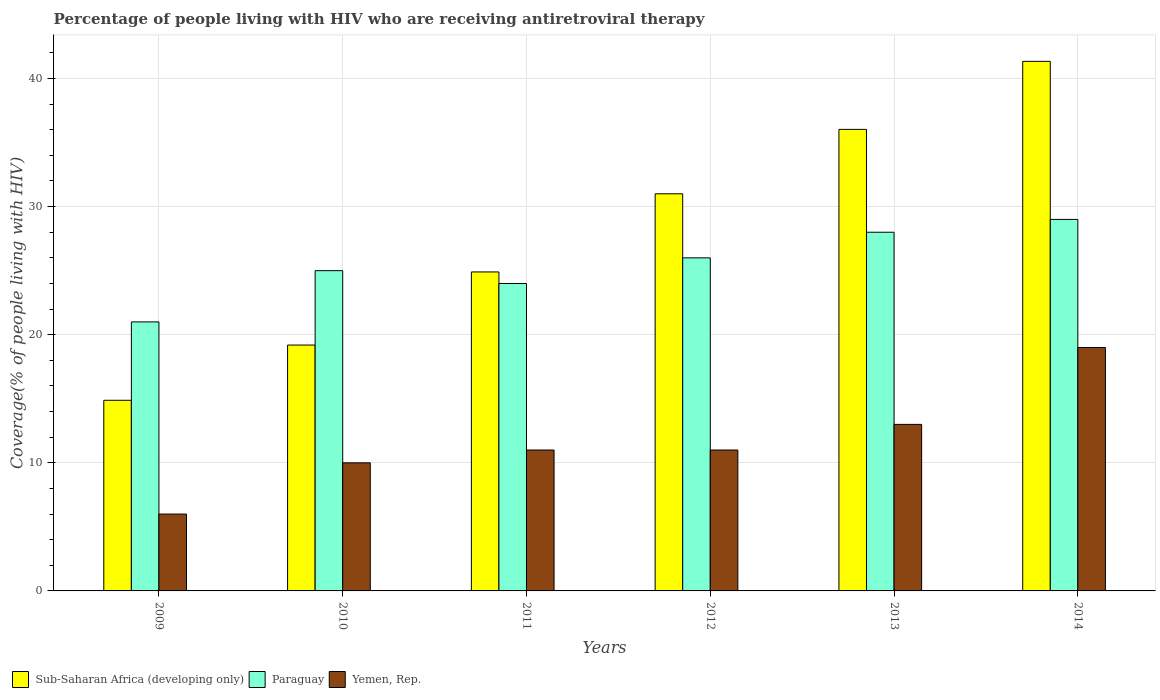How many different coloured bars are there?
Keep it short and to the point. 3. Are the number of bars per tick equal to the number of legend labels?
Keep it short and to the point. Yes. How many bars are there on the 6th tick from the right?
Your response must be concise. 3. What is the label of the 3rd group of bars from the left?
Give a very brief answer. 2011. What is the percentage of the HIV infected people who are receiving antiretroviral therapy in Sub-Saharan Africa (developing only) in 2013?
Offer a terse response. 36.03. Across all years, what is the maximum percentage of the HIV infected people who are receiving antiretroviral therapy in Sub-Saharan Africa (developing only)?
Your answer should be very brief. 41.34. Across all years, what is the minimum percentage of the HIV infected people who are receiving antiretroviral therapy in Sub-Saharan Africa (developing only)?
Give a very brief answer. 14.88. In which year was the percentage of the HIV infected people who are receiving antiretroviral therapy in Paraguay maximum?
Your response must be concise. 2014. In which year was the percentage of the HIV infected people who are receiving antiretroviral therapy in Paraguay minimum?
Ensure brevity in your answer.  2009. What is the total percentage of the HIV infected people who are receiving antiretroviral therapy in Paraguay in the graph?
Provide a succinct answer. 153. What is the difference between the percentage of the HIV infected people who are receiving antiretroviral therapy in Paraguay in 2012 and that in 2014?
Offer a terse response. -3. What is the difference between the percentage of the HIV infected people who are receiving antiretroviral therapy in Sub-Saharan Africa (developing only) in 2011 and the percentage of the HIV infected people who are receiving antiretroviral therapy in Yemen, Rep. in 2012?
Offer a terse response. 13.9. What is the average percentage of the HIV infected people who are receiving antiretroviral therapy in Sub-Saharan Africa (developing only) per year?
Your response must be concise. 27.89. In the year 2012, what is the difference between the percentage of the HIV infected people who are receiving antiretroviral therapy in Paraguay and percentage of the HIV infected people who are receiving antiretroviral therapy in Yemen, Rep.?
Offer a very short reply. 15. In how many years, is the percentage of the HIV infected people who are receiving antiretroviral therapy in Paraguay greater than 28 %?
Make the answer very short. 1. What is the ratio of the percentage of the HIV infected people who are receiving antiretroviral therapy in Yemen, Rep. in 2013 to that in 2014?
Provide a short and direct response. 0.68. Is the percentage of the HIV infected people who are receiving antiretroviral therapy in Sub-Saharan Africa (developing only) in 2010 less than that in 2013?
Your response must be concise. Yes. Is the difference between the percentage of the HIV infected people who are receiving antiretroviral therapy in Paraguay in 2012 and 2014 greater than the difference between the percentage of the HIV infected people who are receiving antiretroviral therapy in Yemen, Rep. in 2012 and 2014?
Provide a succinct answer. Yes. What is the difference between the highest and the second highest percentage of the HIV infected people who are receiving antiretroviral therapy in Yemen, Rep.?
Make the answer very short. 6. What is the difference between the highest and the lowest percentage of the HIV infected people who are receiving antiretroviral therapy in Sub-Saharan Africa (developing only)?
Provide a succinct answer. 26.46. In how many years, is the percentage of the HIV infected people who are receiving antiretroviral therapy in Sub-Saharan Africa (developing only) greater than the average percentage of the HIV infected people who are receiving antiretroviral therapy in Sub-Saharan Africa (developing only) taken over all years?
Keep it short and to the point. 3. Is the sum of the percentage of the HIV infected people who are receiving antiretroviral therapy in Sub-Saharan Africa (developing only) in 2010 and 2011 greater than the maximum percentage of the HIV infected people who are receiving antiretroviral therapy in Yemen, Rep. across all years?
Ensure brevity in your answer.  Yes. What does the 1st bar from the left in 2011 represents?
Offer a terse response. Sub-Saharan Africa (developing only). What does the 2nd bar from the right in 2013 represents?
Offer a terse response. Paraguay. Does the graph contain grids?
Give a very brief answer. Yes. Where does the legend appear in the graph?
Ensure brevity in your answer.  Bottom left. How many legend labels are there?
Give a very brief answer. 3. What is the title of the graph?
Offer a terse response. Percentage of people living with HIV who are receiving antiretroviral therapy. What is the label or title of the Y-axis?
Offer a terse response. Coverage(% of people living with HIV). What is the Coverage(% of people living with HIV) of Sub-Saharan Africa (developing only) in 2009?
Your answer should be compact. 14.88. What is the Coverage(% of people living with HIV) of Paraguay in 2009?
Your response must be concise. 21. What is the Coverage(% of people living with HIV) in Sub-Saharan Africa (developing only) in 2010?
Offer a very short reply. 19.19. What is the Coverage(% of people living with HIV) in Yemen, Rep. in 2010?
Provide a succinct answer. 10. What is the Coverage(% of people living with HIV) of Sub-Saharan Africa (developing only) in 2011?
Offer a very short reply. 24.9. What is the Coverage(% of people living with HIV) in Paraguay in 2011?
Keep it short and to the point. 24. What is the Coverage(% of people living with HIV) in Yemen, Rep. in 2011?
Provide a short and direct response. 11. What is the Coverage(% of people living with HIV) of Sub-Saharan Africa (developing only) in 2012?
Keep it short and to the point. 31. What is the Coverage(% of people living with HIV) in Paraguay in 2012?
Your answer should be compact. 26. What is the Coverage(% of people living with HIV) in Sub-Saharan Africa (developing only) in 2013?
Your answer should be compact. 36.03. What is the Coverage(% of people living with HIV) in Yemen, Rep. in 2013?
Provide a succinct answer. 13. What is the Coverage(% of people living with HIV) in Sub-Saharan Africa (developing only) in 2014?
Provide a succinct answer. 41.34. What is the Coverage(% of people living with HIV) in Yemen, Rep. in 2014?
Offer a very short reply. 19. Across all years, what is the maximum Coverage(% of people living with HIV) in Sub-Saharan Africa (developing only)?
Give a very brief answer. 41.34. Across all years, what is the maximum Coverage(% of people living with HIV) of Paraguay?
Ensure brevity in your answer.  29. Across all years, what is the minimum Coverage(% of people living with HIV) in Sub-Saharan Africa (developing only)?
Your answer should be very brief. 14.88. Across all years, what is the minimum Coverage(% of people living with HIV) in Paraguay?
Offer a terse response. 21. What is the total Coverage(% of people living with HIV) in Sub-Saharan Africa (developing only) in the graph?
Offer a terse response. 167.34. What is the total Coverage(% of people living with HIV) in Paraguay in the graph?
Give a very brief answer. 153. What is the difference between the Coverage(% of people living with HIV) of Sub-Saharan Africa (developing only) in 2009 and that in 2010?
Make the answer very short. -4.31. What is the difference between the Coverage(% of people living with HIV) of Sub-Saharan Africa (developing only) in 2009 and that in 2011?
Ensure brevity in your answer.  -10.02. What is the difference between the Coverage(% of people living with HIV) of Paraguay in 2009 and that in 2011?
Keep it short and to the point. -3. What is the difference between the Coverage(% of people living with HIV) in Yemen, Rep. in 2009 and that in 2011?
Your response must be concise. -5. What is the difference between the Coverage(% of people living with HIV) in Sub-Saharan Africa (developing only) in 2009 and that in 2012?
Offer a very short reply. -16.12. What is the difference between the Coverage(% of people living with HIV) of Paraguay in 2009 and that in 2012?
Provide a succinct answer. -5. What is the difference between the Coverage(% of people living with HIV) of Sub-Saharan Africa (developing only) in 2009 and that in 2013?
Make the answer very short. -21.15. What is the difference between the Coverage(% of people living with HIV) in Sub-Saharan Africa (developing only) in 2009 and that in 2014?
Your answer should be compact. -26.46. What is the difference between the Coverage(% of people living with HIV) in Yemen, Rep. in 2009 and that in 2014?
Make the answer very short. -13. What is the difference between the Coverage(% of people living with HIV) in Sub-Saharan Africa (developing only) in 2010 and that in 2011?
Give a very brief answer. -5.71. What is the difference between the Coverage(% of people living with HIV) in Paraguay in 2010 and that in 2011?
Make the answer very short. 1. What is the difference between the Coverage(% of people living with HIV) in Sub-Saharan Africa (developing only) in 2010 and that in 2012?
Offer a terse response. -11.81. What is the difference between the Coverage(% of people living with HIV) in Yemen, Rep. in 2010 and that in 2012?
Your answer should be compact. -1. What is the difference between the Coverage(% of people living with HIV) in Sub-Saharan Africa (developing only) in 2010 and that in 2013?
Your response must be concise. -16.84. What is the difference between the Coverage(% of people living with HIV) in Sub-Saharan Africa (developing only) in 2010 and that in 2014?
Your answer should be compact. -22.15. What is the difference between the Coverage(% of people living with HIV) in Paraguay in 2010 and that in 2014?
Provide a short and direct response. -4. What is the difference between the Coverage(% of people living with HIV) of Sub-Saharan Africa (developing only) in 2011 and that in 2012?
Provide a succinct answer. -6.1. What is the difference between the Coverage(% of people living with HIV) in Sub-Saharan Africa (developing only) in 2011 and that in 2013?
Keep it short and to the point. -11.13. What is the difference between the Coverage(% of people living with HIV) of Sub-Saharan Africa (developing only) in 2011 and that in 2014?
Offer a very short reply. -16.44. What is the difference between the Coverage(% of people living with HIV) of Paraguay in 2011 and that in 2014?
Provide a short and direct response. -5. What is the difference between the Coverage(% of people living with HIV) in Sub-Saharan Africa (developing only) in 2012 and that in 2013?
Keep it short and to the point. -5.03. What is the difference between the Coverage(% of people living with HIV) in Paraguay in 2012 and that in 2013?
Your response must be concise. -2. What is the difference between the Coverage(% of people living with HIV) of Yemen, Rep. in 2012 and that in 2013?
Offer a very short reply. -2. What is the difference between the Coverage(% of people living with HIV) of Sub-Saharan Africa (developing only) in 2012 and that in 2014?
Provide a succinct answer. -10.34. What is the difference between the Coverage(% of people living with HIV) in Paraguay in 2012 and that in 2014?
Offer a terse response. -3. What is the difference between the Coverage(% of people living with HIV) in Yemen, Rep. in 2012 and that in 2014?
Your response must be concise. -8. What is the difference between the Coverage(% of people living with HIV) of Sub-Saharan Africa (developing only) in 2013 and that in 2014?
Make the answer very short. -5.31. What is the difference between the Coverage(% of people living with HIV) in Yemen, Rep. in 2013 and that in 2014?
Give a very brief answer. -6. What is the difference between the Coverage(% of people living with HIV) in Sub-Saharan Africa (developing only) in 2009 and the Coverage(% of people living with HIV) in Paraguay in 2010?
Your answer should be compact. -10.12. What is the difference between the Coverage(% of people living with HIV) in Sub-Saharan Africa (developing only) in 2009 and the Coverage(% of people living with HIV) in Yemen, Rep. in 2010?
Make the answer very short. 4.88. What is the difference between the Coverage(% of people living with HIV) in Sub-Saharan Africa (developing only) in 2009 and the Coverage(% of people living with HIV) in Paraguay in 2011?
Offer a very short reply. -9.12. What is the difference between the Coverage(% of people living with HIV) of Sub-Saharan Africa (developing only) in 2009 and the Coverage(% of people living with HIV) of Yemen, Rep. in 2011?
Ensure brevity in your answer.  3.88. What is the difference between the Coverage(% of people living with HIV) of Sub-Saharan Africa (developing only) in 2009 and the Coverage(% of people living with HIV) of Paraguay in 2012?
Provide a short and direct response. -11.12. What is the difference between the Coverage(% of people living with HIV) in Sub-Saharan Africa (developing only) in 2009 and the Coverage(% of people living with HIV) in Yemen, Rep. in 2012?
Make the answer very short. 3.88. What is the difference between the Coverage(% of people living with HIV) of Paraguay in 2009 and the Coverage(% of people living with HIV) of Yemen, Rep. in 2012?
Make the answer very short. 10. What is the difference between the Coverage(% of people living with HIV) in Sub-Saharan Africa (developing only) in 2009 and the Coverage(% of people living with HIV) in Paraguay in 2013?
Provide a short and direct response. -13.12. What is the difference between the Coverage(% of people living with HIV) in Sub-Saharan Africa (developing only) in 2009 and the Coverage(% of people living with HIV) in Yemen, Rep. in 2013?
Give a very brief answer. 1.88. What is the difference between the Coverage(% of people living with HIV) of Sub-Saharan Africa (developing only) in 2009 and the Coverage(% of people living with HIV) of Paraguay in 2014?
Provide a short and direct response. -14.12. What is the difference between the Coverage(% of people living with HIV) in Sub-Saharan Africa (developing only) in 2009 and the Coverage(% of people living with HIV) in Yemen, Rep. in 2014?
Give a very brief answer. -4.12. What is the difference between the Coverage(% of people living with HIV) of Paraguay in 2009 and the Coverage(% of people living with HIV) of Yemen, Rep. in 2014?
Keep it short and to the point. 2. What is the difference between the Coverage(% of people living with HIV) in Sub-Saharan Africa (developing only) in 2010 and the Coverage(% of people living with HIV) in Paraguay in 2011?
Provide a succinct answer. -4.81. What is the difference between the Coverage(% of people living with HIV) of Sub-Saharan Africa (developing only) in 2010 and the Coverage(% of people living with HIV) of Yemen, Rep. in 2011?
Ensure brevity in your answer.  8.19. What is the difference between the Coverage(% of people living with HIV) in Paraguay in 2010 and the Coverage(% of people living with HIV) in Yemen, Rep. in 2011?
Your answer should be very brief. 14. What is the difference between the Coverage(% of people living with HIV) of Sub-Saharan Africa (developing only) in 2010 and the Coverage(% of people living with HIV) of Paraguay in 2012?
Make the answer very short. -6.81. What is the difference between the Coverage(% of people living with HIV) of Sub-Saharan Africa (developing only) in 2010 and the Coverage(% of people living with HIV) of Yemen, Rep. in 2012?
Keep it short and to the point. 8.19. What is the difference between the Coverage(% of people living with HIV) of Sub-Saharan Africa (developing only) in 2010 and the Coverage(% of people living with HIV) of Paraguay in 2013?
Make the answer very short. -8.81. What is the difference between the Coverage(% of people living with HIV) of Sub-Saharan Africa (developing only) in 2010 and the Coverage(% of people living with HIV) of Yemen, Rep. in 2013?
Provide a succinct answer. 6.19. What is the difference between the Coverage(% of people living with HIV) of Sub-Saharan Africa (developing only) in 2010 and the Coverage(% of people living with HIV) of Paraguay in 2014?
Give a very brief answer. -9.81. What is the difference between the Coverage(% of people living with HIV) in Sub-Saharan Africa (developing only) in 2010 and the Coverage(% of people living with HIV) in Yemen, Rep. in 2014?
Offer a terse response. 0.19. What is the difference between the Coverage(% of people living with HIV) of Paraguay in 2010 and the Coverage(% of people living with HIV) of Yemen, Rep. in 2014?
Your response must be concise. 6. What is the difference between the Coverage(% of people living with HIV) in Sub-Saharan Africa (developing only) in 2011 and the Coverage(% of people living with HIV) in Paraguay in 2012?
Keep it short and to the point. -1.1. What is the difference between the Coverage(% of people living with HIV) of Sub-Saharan Africa (developing only) in 2011 and the Coverage(% of people living with HIV) of Yemen, Rep. in 2012?
Provide a succinct answer. 13.9. What is the difference between the Coverage(% of people living with HIV) in Sub-Saharan Africa (developing only) in 2011 and the Coverage(% of people living with HIV) in Paraguay in 2013?
Your answer should be compact. -3.1. What is the difference between the Coverage(% of people living with HIV) of Sub-Saharan Africa (developing only) in 2011 and the Coverage(% of people living with HIV) of Yemen, Rep. in 2013?
Your answer should be very brief. 11.9. What is the difference between the Coverage(% of people living with HIV) in Sub-Saharan Africa (developing only) in 2011 and the Coverage(% of people living with HIV) in Paraguay in 2014?
Give a very brief answer. -4.1. What is the difference between the Coverage(% of people living with HIV) of Sub-Saharan Africa (developing only) in 2011 and the Coverage(% of people living with HIV) of Yemen, Rep. in 2014?
Offer a very short reply. 5.9. What is the difference between the Coverage(% of people living with HIV) of Sub-Saharan Africa (developing only) in 2012 and the Coverage(% of people living with HIV) of Paraguay in 2013?
Give a very brief answer. 3. What is the difference between the Coverage(% of people living with HIV) in Sub-Saharan Africa (developing only) in 2012 and the Coverage(% of people living with HIV) in Yemen, Rep. in 2013?
Give a very brief answer. 18. What is the difference between the Coverage(% of people living with HIV) of Paraguay in 2012 and the Coverage(% of people living with HIV) of Yemen, Rep. in 2013?
Make the answer very short. 13. What is the difference between the Coverage(% of people living with HIV) in Sub-Saharan Africa (developing only) in 2012 and the Coverage(% of people living with HIV) in Paraguay in 2014?
Offer a very short reply. 2. What is the difference between the Coverage(% of people living with HIV) of Sub-Saharan Africa (developing only) in 2012 and the Coverage(% of people living with HIV) of Yemen, Rep. in 2014?
Provide a short and direct response. 12. What is the difference between the Coverage(% of people living with HIV) of Sub-Saharan Africa (developing only) in 2013 and the Coverage(% of people living with HIV) of Paraguay in 2014?
Keep it short and to the point. 7.03. What is the difference between the Coverage(% of people living with HIV) of Sub-Saharan Africa (developing only) in 2013 and the Coverage(% of people living with HIV) of Yemen, Rep. in 2014?
Offer a very short reply. 17.03. What is the average Coverage(% of people living with HIV) in Sub-Saharan Africa (developing only) per year?
Offer a very short reply. 27.89. What is the average Coverage(% of people living with HIV) in Paraguay per year?
Your answer should be compact. 25.5. What is the average Coverage(% of people living with HIV) of Yemen, Rep. per year?
Give a very brief answer. 11.67. In the year 2009, what is the difference between the Coverage(% of people living with HIV) of Sub-Saharan Africa (developing only) and Coverage(% of people living with HIV) of Paraguay?
Your response must be concise. -6.12. In the year 2009, what is the difference between the Coverage(% of people living with HIV) of Sub-Saharan Africa (developing only) and Coverage(% of people living with HIV) of Yemen, Rep.?
Ensure brevity in your answer.  8.88. In the year 2010, what is the difference between the Coverage(% of people living with HIV) in Sub-Saharan Africa (developing only) and Coverage(% of people living with HIV) in Paraguay?
Give a very brief answer. -5.81. In the year 2010, what is the difference between the Coverage(% of people living with HIV) of Sub-Saharan Africa (developing only) and Coverage(% of people living with HIV) of Yemen, Rep.?
Provide a succinct answer. 9.19. In the year 2010, what is the difference between the Coverage(% of people living with HIV) of Paraguay and Coverage(% of people living with HIV) of Yemen, Rep.?
Give a very brief answer. 15. In the year 2011, what is the difference between the Coverage(% of people living with HIV) in Sub-Saharan Africa (developing only) and Coverage(% of people living with HIV) in Paraguay?
Give a very brief answer. 0.9. In the year 2011, what is the difference between the Coverage(% of people living with HIV) in Sub-Saharan Africa (developing only) and Coverage(% of people living with HIV) in Yemen, Rep.?
Your answer should be compact. 13.9. In the year 2012, what is the difference between the Coverage(% of people living with HIV) of Sub-Saharan Africa (developing only) and Coverage(% of people living with HIV) of Paraguay?
Offer a very short reply. 5. In the year 2012, what is the difference between the Coverage(% of people living with HIV) of Sub-Saharan Africa (developing only) and Coverage(% of people living with HIV) of Yemen, Rep.?
Provide a short and direct response. 20. In the year 2013, what is the difference between the Coverage(% of people living with HIV) in Sub-Saharan Africa (developing only) and Coverage(% of people living with HIV) in Paraguay?
Give a very brief answer. 8.03. In the year 2013, what is the difference between the Coverage(% of people living with HIV) in Sub-Saharan Africa (developing only) and Coverage(% of people living with HIV) in Yemen, Rep.?
Your answer should be very brief. 23.03. In the year 2014, what is the difference between the Coverage(% of people living with HIV) of Sub-Saharan Africa (developing only) and Coverage(% of people living with HIV) of Paraguay?
Provide a short and direct response. 12.34. In the year 2014, what is the difference between the Coverage(% of people living with HIV) of Sub-Saharan Africa (developing only) and Coverage(% of people living with HIV) of Yemen, Rep.?
Keep it short and to the point. 22.34. In the year 2014, what is the difference between the Coverage(% of people living with HIV) of Paraguay and Coverage(% of people living with HIV) of Yemen, Rep.?
Your answer should be very brief. 10. What is the ratio of the Coverage(% of people living with HIV) of Sub-Saharan Africa (developing only) in 2009 to that in 2010?
Your answer should be compact. 0.78. What is the ratio of the Coverage(% of people living with HIV) of Paraguay in 2009 to that in 2010?
Your response must be concise. 0.84. What is the ratio of the Coverage(% of people living with HIV) of Sub-Saharan Africa (developing only) in 2009 to that in 2011?
Your response must be concise. 0.6. What is the ratio of the Coverage(% of people living with HIV) in Paraguay in 2009 to that in 2011?
Offer a very short reply. 0.88. What is the ratio of the Coverage(% of people living with HIV) of Yemen, Rep. in 2009 to that in 2011?
Give a very brief answer. 0.55. What is the ratio of the Coverage(% of people living with HIV) in Sub-Saharan Africa (developing only) in 2009 to that in 2012?
Provide a succinct answer. 0.48. What is the ratio of the Coverage(% of people living with HIV) of Paraguay in 2009 to that in 2012?
Your answer should be very brief. 0.81. What is the ratio of the Coverage(% of people living with HIV) of Yemen, Rep. in 2009 to that in 2012?
Provide a short and direct response. 0.55. What is the ratio of the Coverage(% of people living with HIV) of Sub-Saharan Africa (developing only) in 2009 to that in 2013?
Provide a succinct answer. 0.41. What is the ratio of the Coverage(% of people living with HIV) of Yemen, Rep. in 2009 to that in 2013?
Provide a short and direct response. 0.46. What is the ratio of the Coverage(% of people living with HIV) in Sub-Saharan Africa (developing only) in 2009 to that in 2014?
Offer a terse response. 0.36. What is the ratio of the Coverage(% of people living with HIV) in Paraguay in 2009 to that in 2014?
Offer a very short reply. 0.72. What is the ratio of the Coverage(% of people living with HIV) of Yemen, Rep. in 2009 to that in 2014?
Keep it short and to the point. 0.32. What is the ratio of the Coverage(% of people living with HIV) in Sub-Saharan Africa (developing only) in 2010 to that in 2011?
Make the answer very short. 0.77. What is the ratio of the Coverage(% of people living with HIV) of Paraguay in 2010 to that in 2011?
Your answer should be compact. 1.04. What is the ratio of the Coverage(% of people living with HIV) in Yemen, Rep. in 2010 to that in 2011?
Give a very brief answer. 0.91. What is the ratio of the Coverage(% of people living with HIV) in Sub-Saharan Africa (developing only) in 2010 to that in 2012?
Provide a succinct answer. 0.62. What is the ratio of the Coverage(% of people living with HIV) of Paraguay in 2010 to that in 2012?
Your answer should be very brief. 0.96. What is the ratio of the Coverage(% of people living with HIV) in Sub-Saharan Africa (developing only) in 2010 to that in 2013?
Give a very brief answer. 0.53. What is the ratio of the Coverage(% of people living with HIV) in Paraguay in 2010 to that in 2013?
Your answer should be compact. 0.89. What is the ratio of the Coverage(% of people living with HIV) of Yemen, Rep. in 2010 to that in 2013?
Provide a succinct answer. 0.77. What is the ratio of the Coverage(% of people living with HIV) of Sub-Saharan Africa (developing only) in 2010 to that in 2014?
Provide a short and direct response. 0.46. What is the ratio of the Coverage(% of people living with HIV) in Paraguay in 2010 to that in 2014?
Offer a terse response. 0.86. What is the ratio of the Coverage(% of people living with HIV) of Yemen, Rep. in 2010 to that in 2014?
Make the answer very short. 0.53. What is the ratio of the Coverage(% of people living with HIV) in Sub-Saharan Africa (developing only) in 2011 to that in 2012?
Offer a terse response. 0.8. What is the ratio of the Coverage(% of people living with HIV) of Yemen, Rep. in 2011 to that in 2012?
Your answer should be compact. 1. What is the ratio of the Coverage(% of people living with HIV) of Sub-Saharan Africa (developing only) in 2011 to that in 2013?
Provide a succinct answer. 0.69. What is the ratio of the Coverage(% of people living with HIV) in Paraguay in 2011 to that in 2013?
Ensure brevity in your answer.  0.86. What is the ratio of the Coverage(% of people living with HIV) of Yemen, Rep. in 2011 to that in 2013?
Give a very brief answer. 0.85. What is the ratio of the Coverage(% of people living with HIV) in Sub-Saharan Africa (developing only) in 2011 to that in 2014?
Your response must be concise. 0.6. What is the ratio of the Coverage(% of people living with HIV) in Paraguay in 2011 to that in 2014?
Your answer should be compact. 0.83. What is the ratio of the Coverage(% of people living with HIV) of Yemen, Rep. in 2011 to that in 2014?
Ensure brevity in your answer.  0.58. What is the ratio of the Coverage(% of people living with HIV) of Sub-Saharan Africa (developing only) in 2012 to that in 2013?
Offer a very short reply. 0.86. What is the ratio of the Coverage(% of people living with HIV) of Paraguay in 2012 to that in 2013?
Ensure brevity in your answer.  0.93. What is the ratio of the Coverage(% of people living with HIV) in Yemen, Rep. in 2012 to that in 2013?
Your answer should be compact. 0.85. What is the ratio of the Coverage(% of people living with HIV) of Sub-Saharan Africa (developing only) in 2012 to that in 2014?
Provide a succinct answer. 0.75. What is the ratio of the Coverage(% of people living with HIV) of Paraguay in 2012 to that in 2014?
Offer a very short reply. 0.9. What is the ratio of the Coverage(% of people living with HIV) in Yemen, Rep. in 2012 to that in 2014?
Your response must be concise. 0.58. What is the ratio of the Coverage(% of people living with HIV) of Sub-Saharan Africa (developing only) in 2013 to that in 2014?
Offer a terse response. 0.87. What is the ratio of the Coverage(% of people living with HIV) of Paraguay in 2013 to that in 2014?
Your response must be concise. 0.97. What is the ratio of the Coverage(% of people living with HIV) of Yemen, Rep. in 2013 to that in 2014?
Keep it short and to the point. 0.68. What is the difference between the highest and the second highest Coverage(% of people living with HIV) of Sub-Saharan Africa (developing only)?
Your response must be concise. 5.31. What is the difference between the highest and the second highest Coverage(% of people living with HIV) in Paraguay?
Offer a very short reply. 1. What is the difference between the highest and the lowest Coverage(% of people living with HIV) of Sub-Saharan Africa (developing only)?
Provide a succinct answer. 26.46. What is the difference between the highest and the lowest Coverage(% of people living with HIV) of Yemen, Rep.?
Keep it short and to the point. 13. 